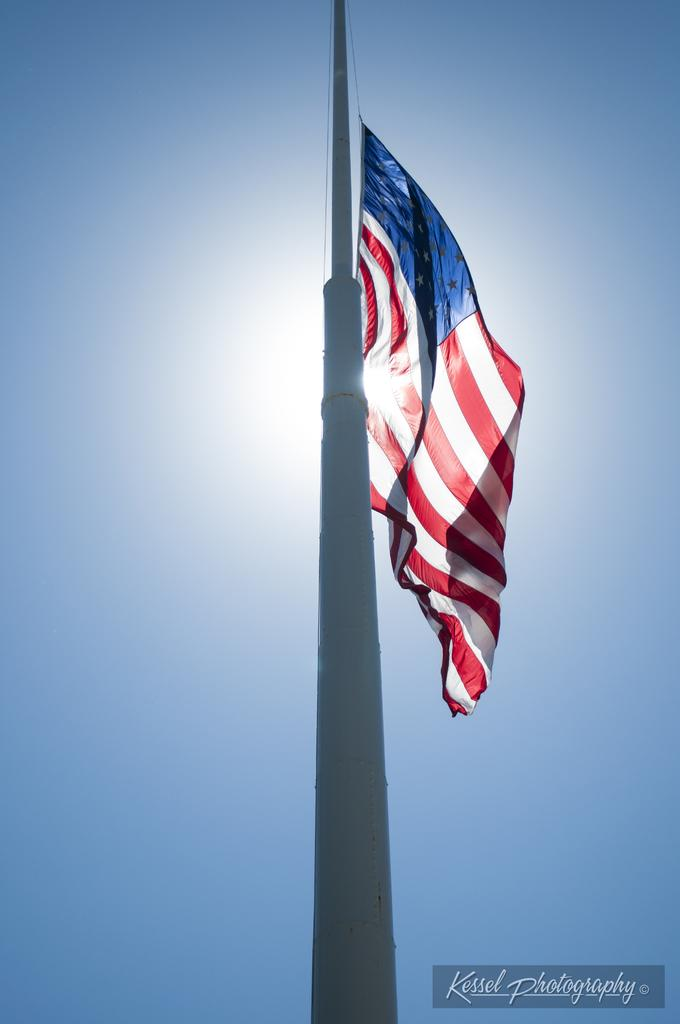What is located on the big pole in the image? There is a flag on a big pole in the image. What can be found at the bottom of the image? There is text written at the bottom of the image. What is visible in the background of the image? The sky is visible in the background of the image. How many zebras can be seen grazing in the background of the image? There are no zebras present in the image; it only features a flag on a big pole and text at the bottom. 